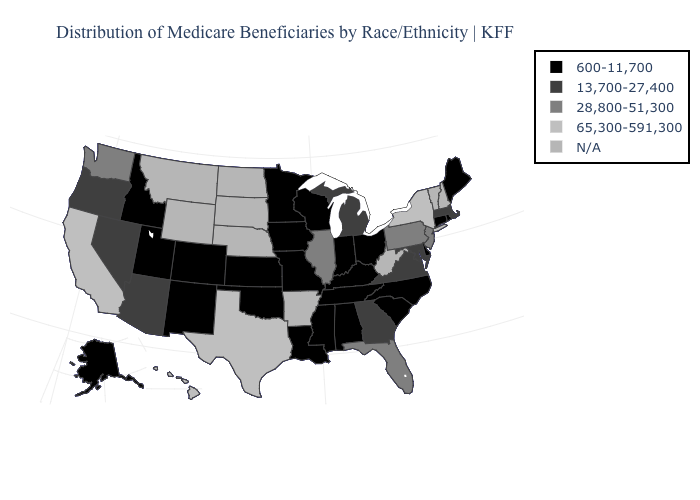Which states hav the highest value in the Northeast?
Keep it brief. New York. What is the value of Ohio?
Quick response, please. 600-11,700. Does the map have missing data?
Give a very brief answer. Yes. Among the states that border Louisiana , which have the lowest value?
Write a very short answer. Mississippi. Does New York have the highest value in the USA?
Quick response, please. Yes. What is the value of North Carolina?
Quick response, please. 600-11,700. How many symbols are there in the legend?
Give a very brief answer. 5. Name the states that have a value in the range 600-11,700?
Keep it brief. Alabama, Alaska, Colorado, Connecticut, Delaware, Idaho, Indiana, Iowa, Kansas, Kentucky, Louisiana, Maine, Minnesota, Mississippi, Missouri, New Mexico, North Carolina, Ohio, Oklahoma, Rhode Island, South Carolina, Tennessee, Utah, Wisconsin. Name the states that have a value in the range 28,800-51,300?
Short answer required. Florida, Illinois, New Jersey, Pennsylvania, Washington. Name the states that have a value in the range 28,800-51,300?
Answer briefly. Florida, Illinois, New Jersey, Pennsylvania, Washington. Does Hawaii have the highest value in the West?
Answer briefly. Yes. What is the value of California?
Write a very short answer. 65,300-591,300. Which states hav the highest value in the South?
Short answer required. Texas. 